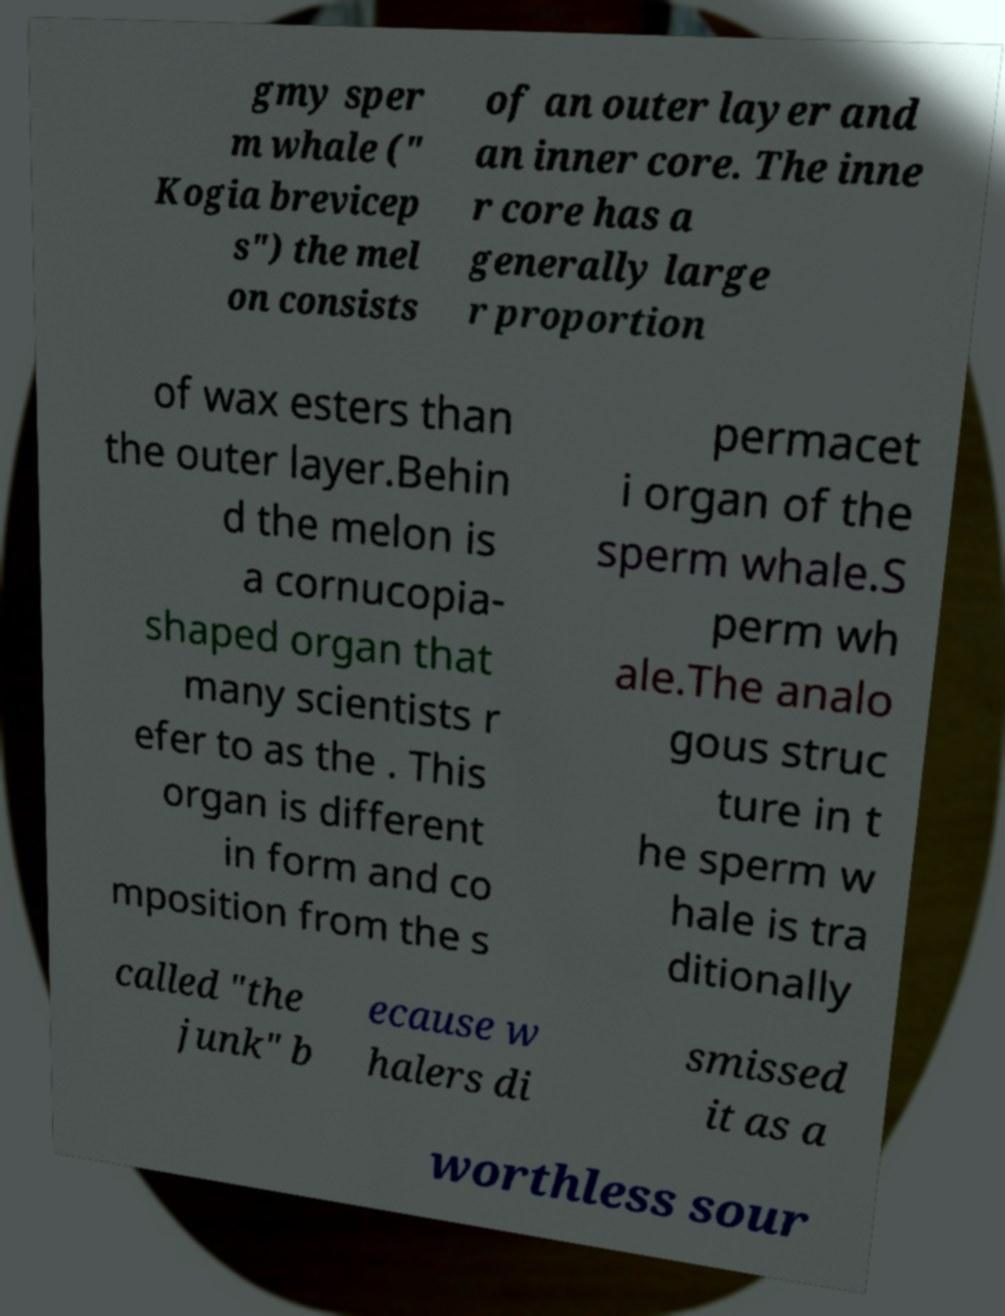I need the written content from this picture converted into text. Can you do that? gmy sper m whale (" Kogia brevicep s") the mel on consists of an outer layer and an inner core. The inne r core has a generally large r proportion of wax esters than the outer layer.Behin d the melon is a cornucopia- shaped organ that many scientists r efer to as the . This organ is different in form and co mposition from the s permacet i organ of the sperm whale.S perm wh ale.The analo gous struc ture in t he sperm w hale is tra ditionally called "the junk" b ecause w halers di smissed it as a worthless sour 